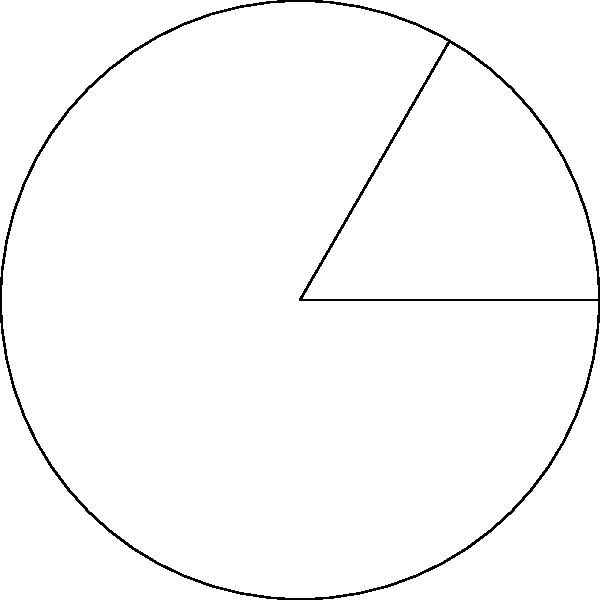In the context of architectural design software, you're developing a feature to calculate curved surface areas. Given a circle with radius $r = 10$ meters and an inscribed angle $\theta = 60°$, determine the length of the arc $\widehat{AB}$. How would you implement this calculation in your software to ensure accuracy in architectural measurements? To calculate the length of the arc $\widehat{AB}$, we can follow these steps:

1) First, recall the formula for arc length:
   $s = r\theta$
   where $s$ is the arc length, $r$ is the radius, and $\theta$ is the central angle in radians.

2) We're given the inscribed angle, which is half the central angle. So, the central angle is:
   $\text{Central angle} = 2 \times \text{Inscribed angle} = 2 \times 60° = 120°$

3) Convert the central angle from degrees to radians:
   $120° \times \frac{\pi}{180°} = \frac{2\pi}{3}$ radians

4) Now we can apply the arc length formula:
   $s = r\theta = 10 \times \frac{2\pi}{3} = \frac{20\pi}{3}$ meters

5) To implement this in software:
   - Define constants: `PI = 3.14159265359`
   - Create a function: `arcLength(radius, inscribedAngle)`
   - Inside the function:
     ```
     centralAngle = 2 * inscribedAngle
     centralAngleRadians = centralAngle * (PI / 180)
     arcLength = radius * centralAngleRadians
     return arcLength
     ```

This implementation ensures accurate calculations for various architectural designs involving circular elements.
Answer: $\frac{20\pi}{3}$ meters 